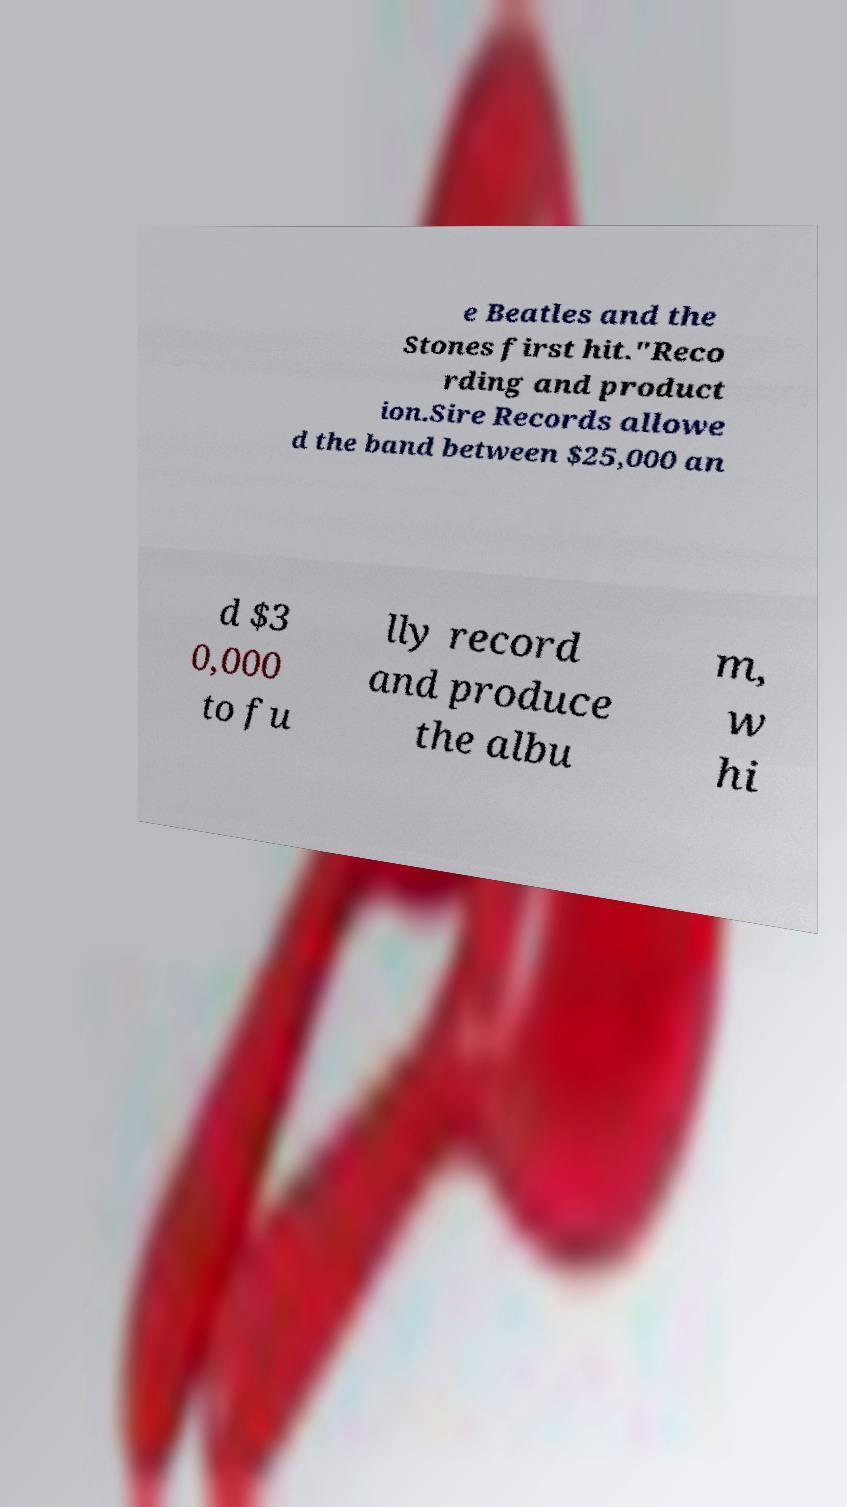Please read and relay the text visible in this image. What does it say? e Beatles and the Stones first hit."Reco rding and product ion.Sire Records allowe d the band between $25,000 an d $3 0,000 to fu lly record and produce the albu m, w hi 